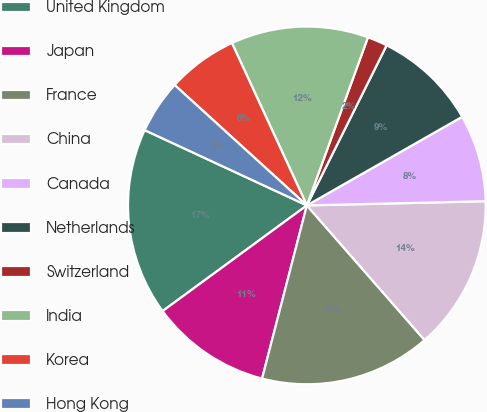Convert chart to OTSL. <chart><loc_0><loc_0><loc_500><loc_500><pie_chart><fcel>United Kingdom<fcel>Japan<fcel>France<fcel>China<fcel>Canada<fcel>Netherlands<fcel>Switzerland<fcel>India<fcel>Korea<fcel>Hong Kong<nl><fcel>16.98%<fcel>10.91%<fcel>15.46%<fcel>13.94%<fcel>7.88%<fcel>9.39%<fcel>1.81%<fcel>12.43%<fcel>6.36%<fcel>4.84%<nl></chart> 